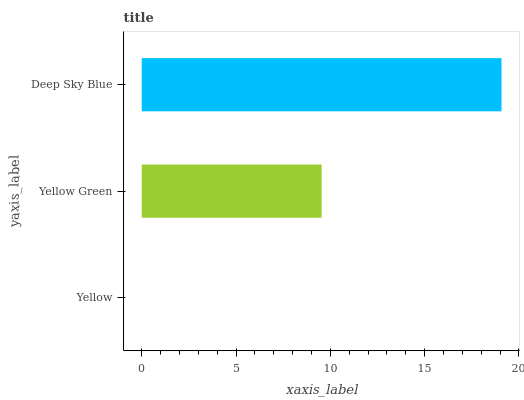Is Yellow the minimum?
Answer yes or no. Yes. Is Deep Sky Blue the maximum?
Answer yes or no. Yes. Is Yellow Green the minimum?
Answer yes or no. No. Is Yellow Green the maximum?
Answer yes or no. No. Is Yellow Green greater than Yellow?
Answer yes or no. Yes. Is Yellow less than Yellow Green?
Answer yes or no. Yes. Is Yellow greater than Yellow Green?
Answer yes or no. No. Is Yellow Green less than Yellow?
Answer yes or no. No. Is Yellow Green the high median?
Answer yes or no. Yes. Is Yellow Green the low median?
Answer yes or no. Yes. Is Deep Sky Blue the high median?
Answer yes or no. No. Is Yellow the low median?
Answer yes or no. No. 